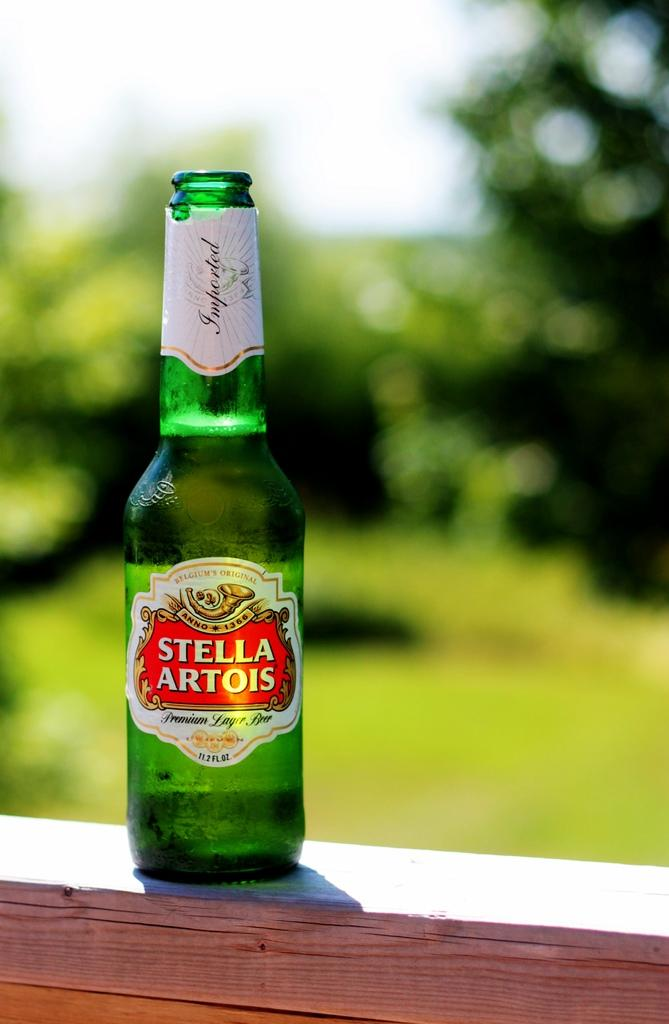<image>
Present a compact description of the photo's key features. A green bottle of beer says Stella Artois. 